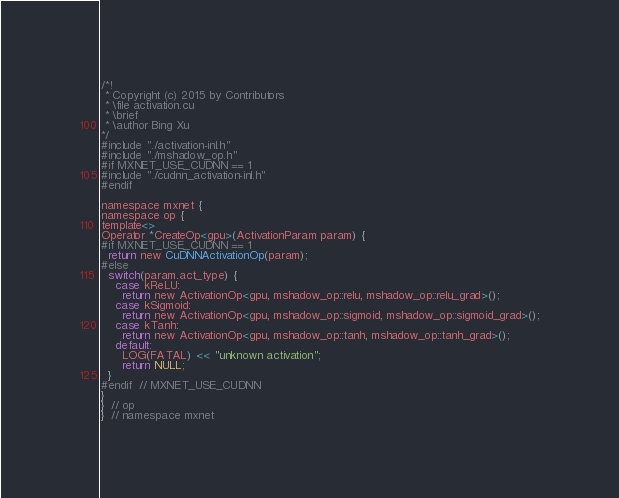<code> <loc_0><loc_0><loc_500><loc_500><_Cuda_>/*!
 * Copyright (c) 2015 by Contributors
 * \file activation.cu
 * \brief
 * \author Bing Xu
*/
#include "./activation-inl.h"
#include "./mshadow_op.h"
#if MXNET_USE_CUDNN == 1
#include "./cudnn_activation-inl.h"
#endif

namespace mxnet {
namespace op {
template<>
Operator *CreateOp<gpu>(ActivationParam param) {
#if MXNET_USE_CUDNN == 1
  return new CuDNNActivationOp(param);
#else
  switch(param.act_type) {
    case kReLU:
      return new ActivationOp<gpu, mshadow_op::relu, mshadow_op::relu_grad>();
    case kSigmoid:
      return new ActivationOp<gpu, mshadow_op::sigmoid, mshadow_op::sigmoid_grad>();
    case kTanh:
      return new ActivationOp<gpu, mshadow_op::tanh, mshadow_op::tanh_grad>();
    default:
      LOG(FATAL) << "unknown activation";
      return NULL;
  }
#endif  // MXNET_USE_CUDNN
}
}  // op
}  // namespace mxnet

</code> 